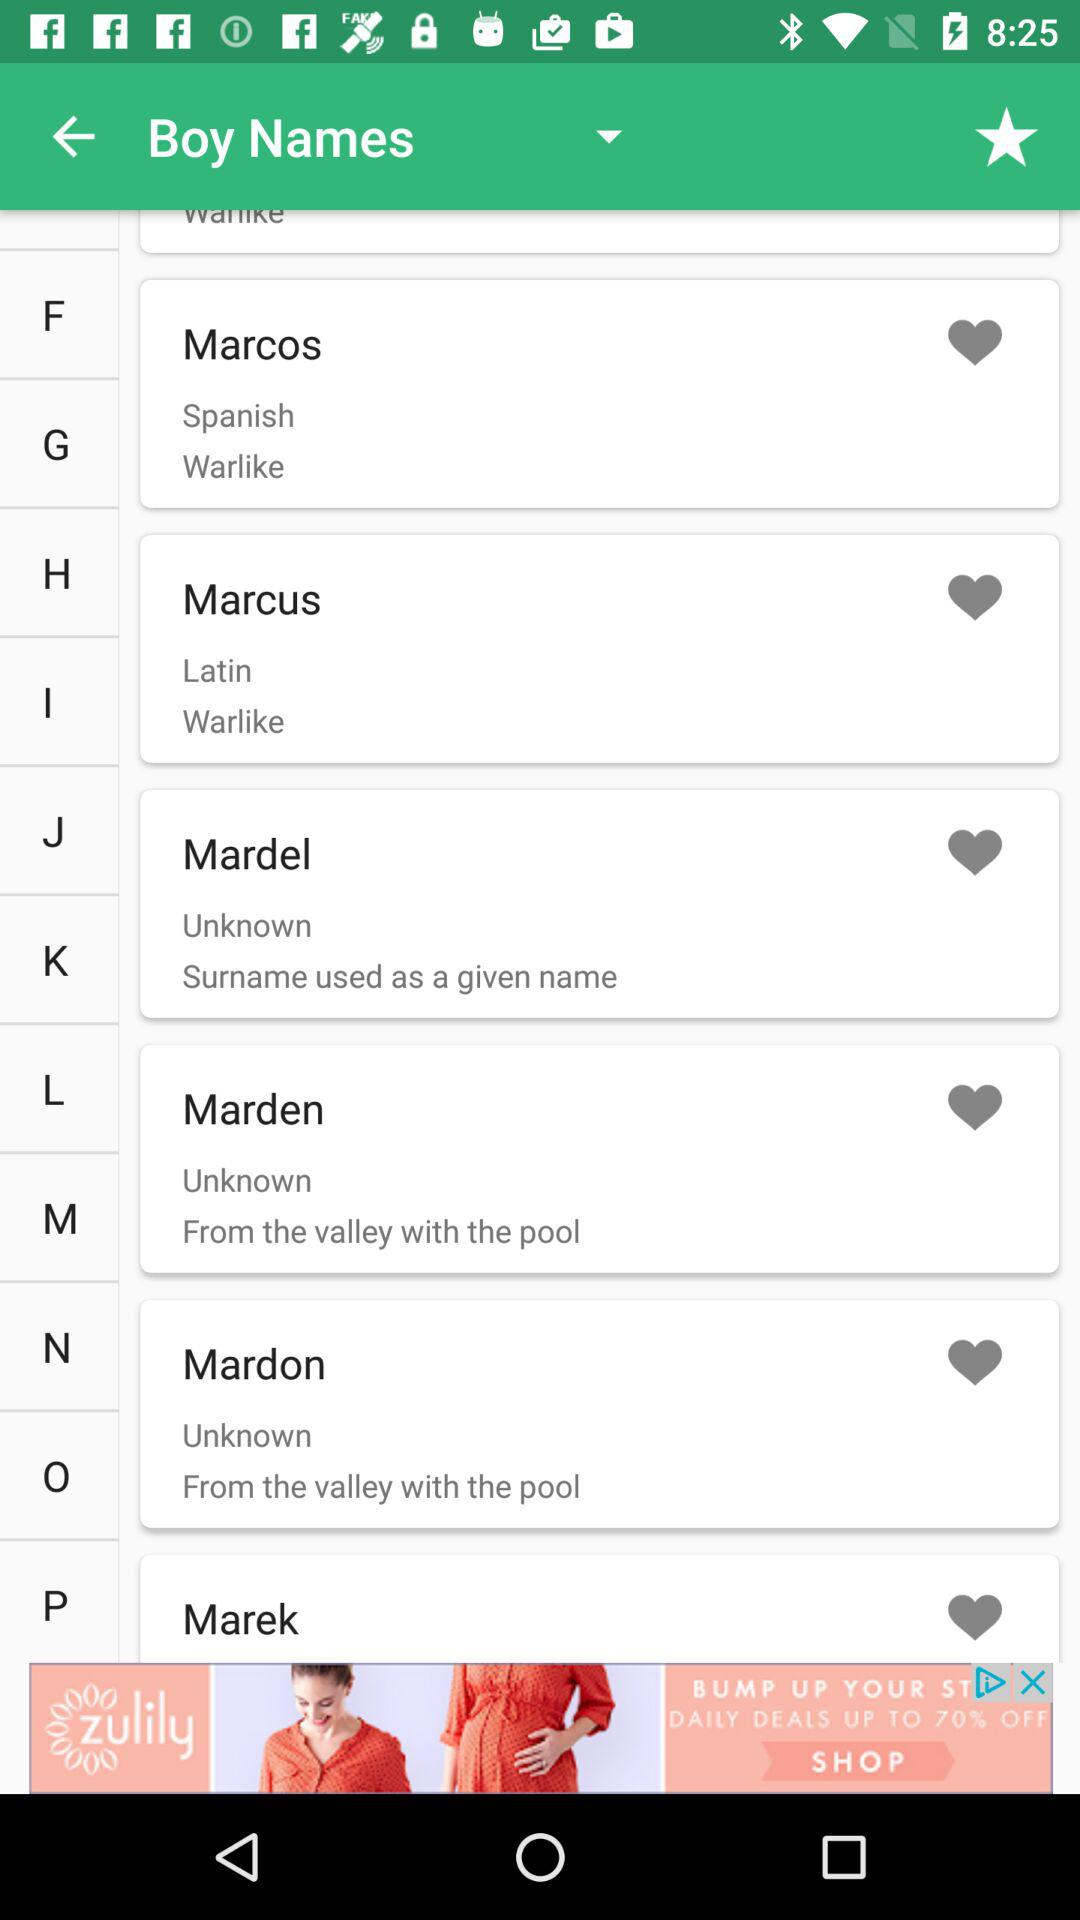How many boys' names are there that begin with the letter F?
When the provided information is insufficient, respond with <no answer>. <no answer> 